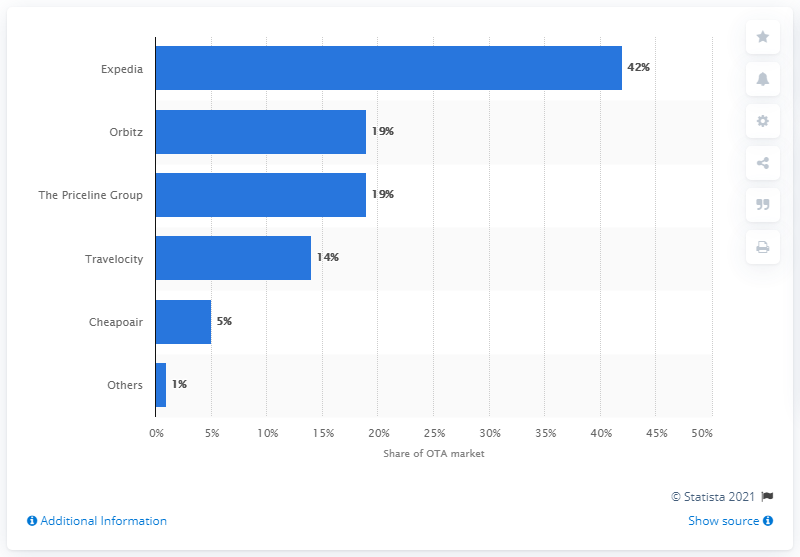Specify some key components in this picture. In 2013, Expedia was the Over-the-Top (OTT) platform with the largest share of the U.S. market. 